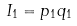<formula> <loc_0><loc_0><loc_500><loc_500>I _ { 1 } = p _ { 1 } q _ { 1 }</formula> 